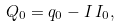<formula> <loc_0><loc_0><loc_500><loc_500>Q _ { 0 } = q _ { 0 } - I \, I _ { 0 } ,</formula> 